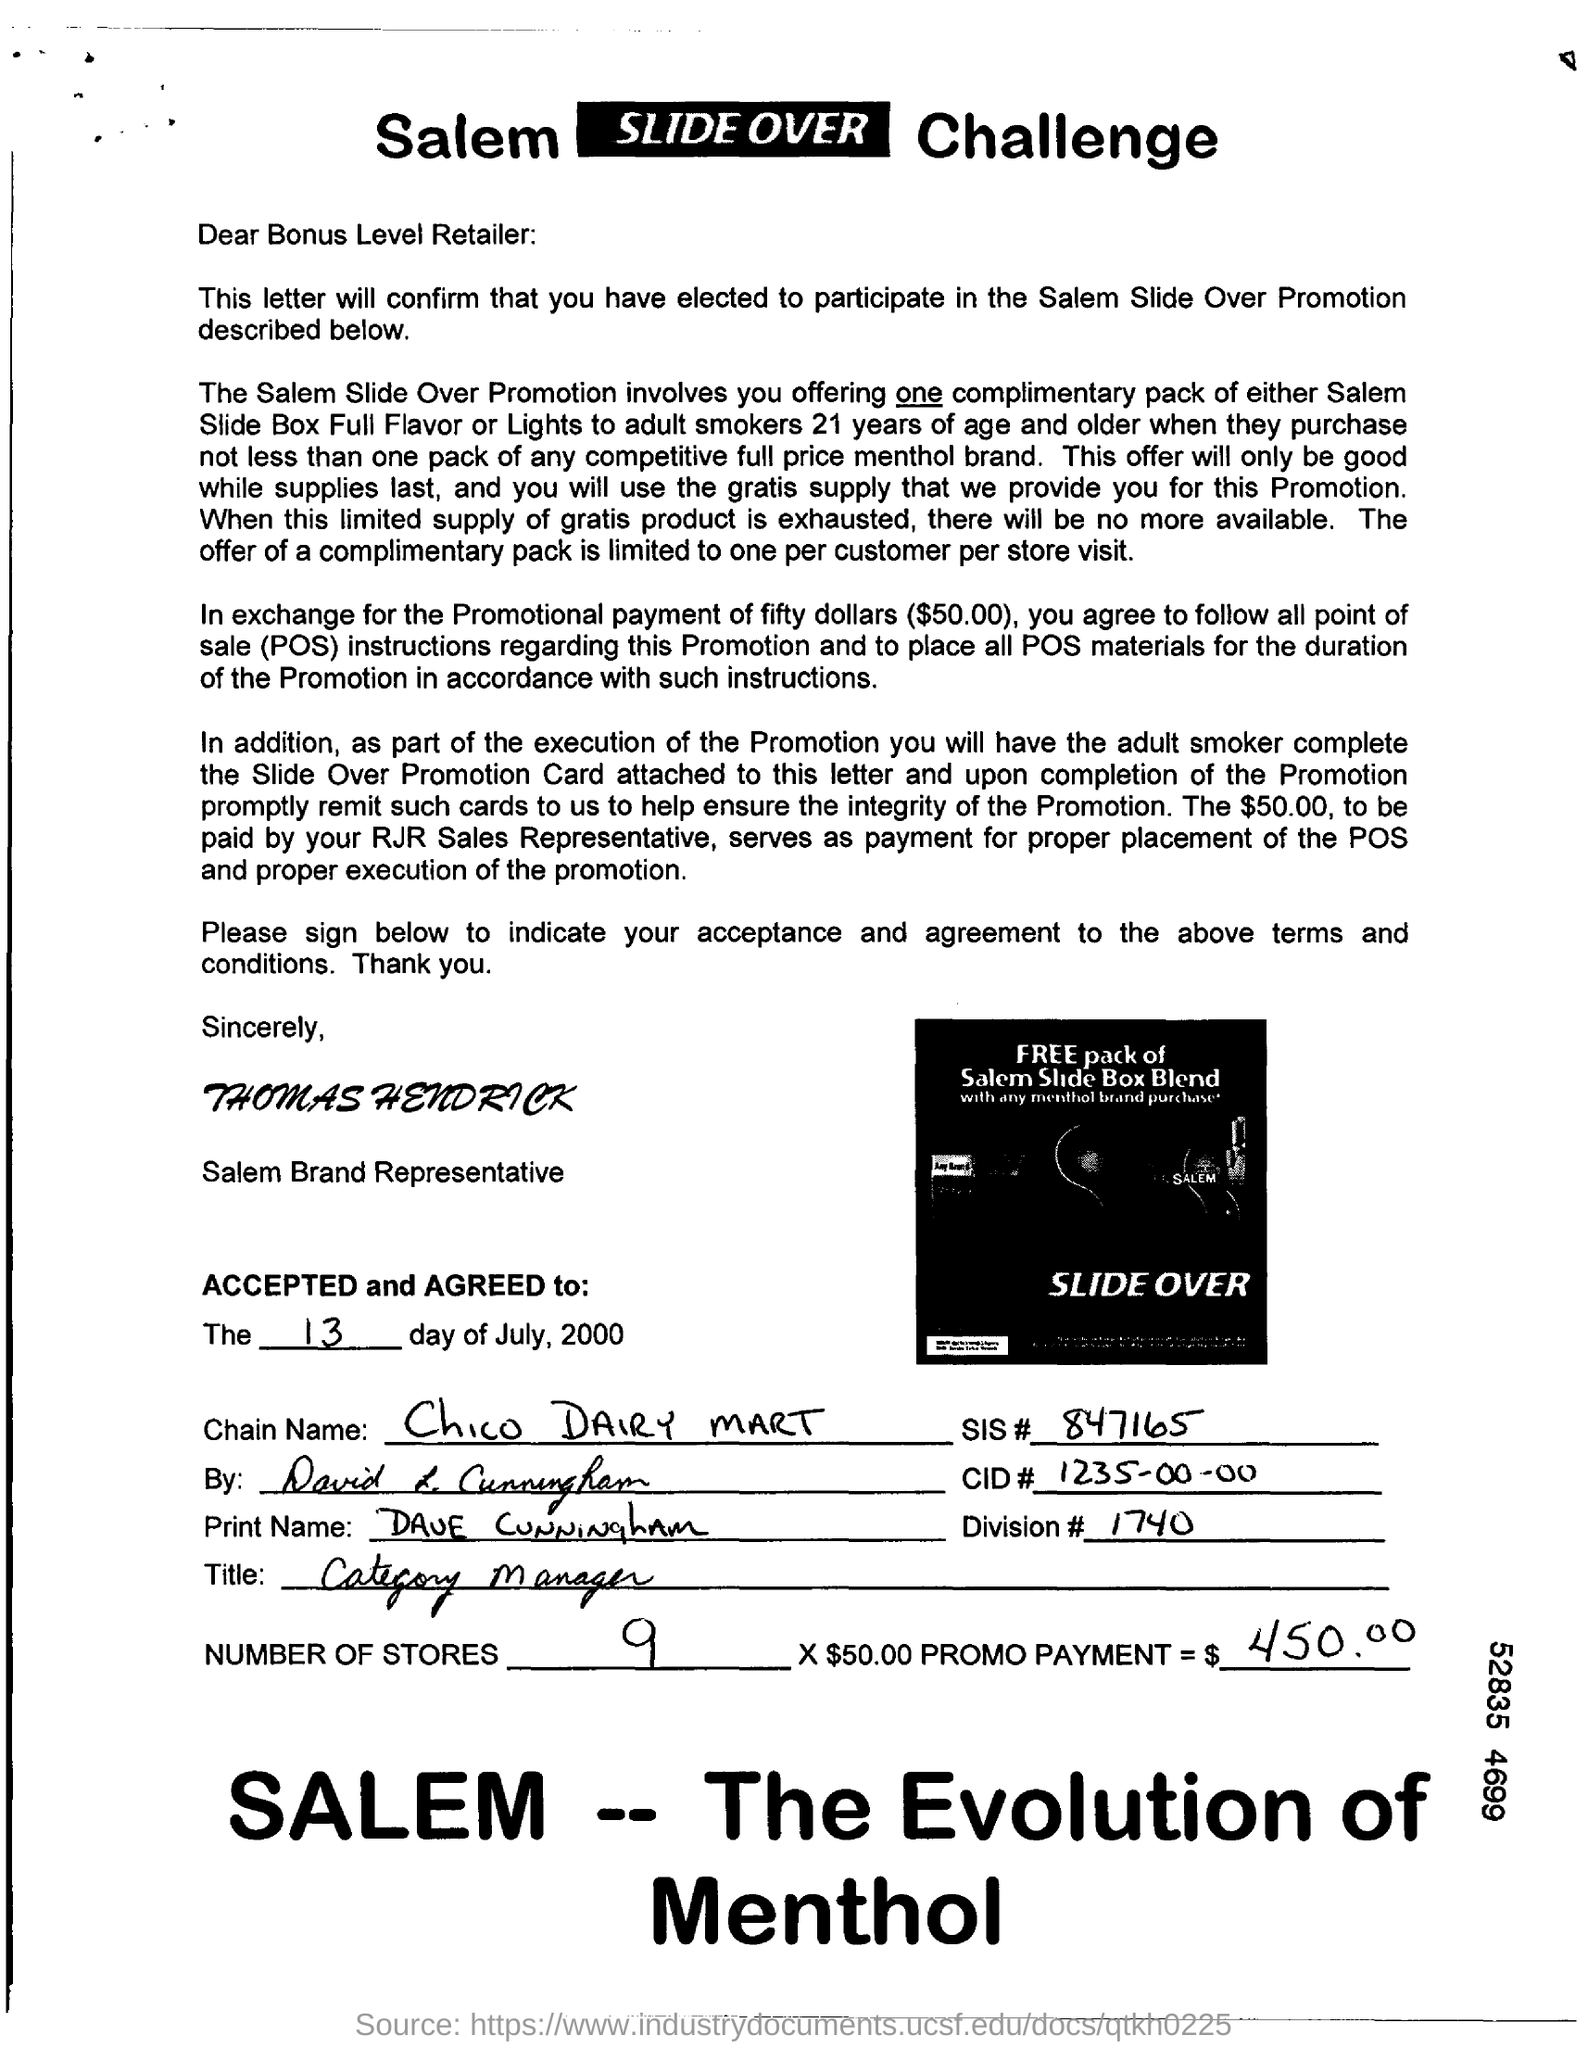Indicate a few pertinent items in this graphic. The identifier '1235-00-00' is known as a CID# (Component IDentifier Number). Chico Dairy Mart is the name of the chain. What is SIS#? The number is 847165... The document lists a total of 9 stores. 